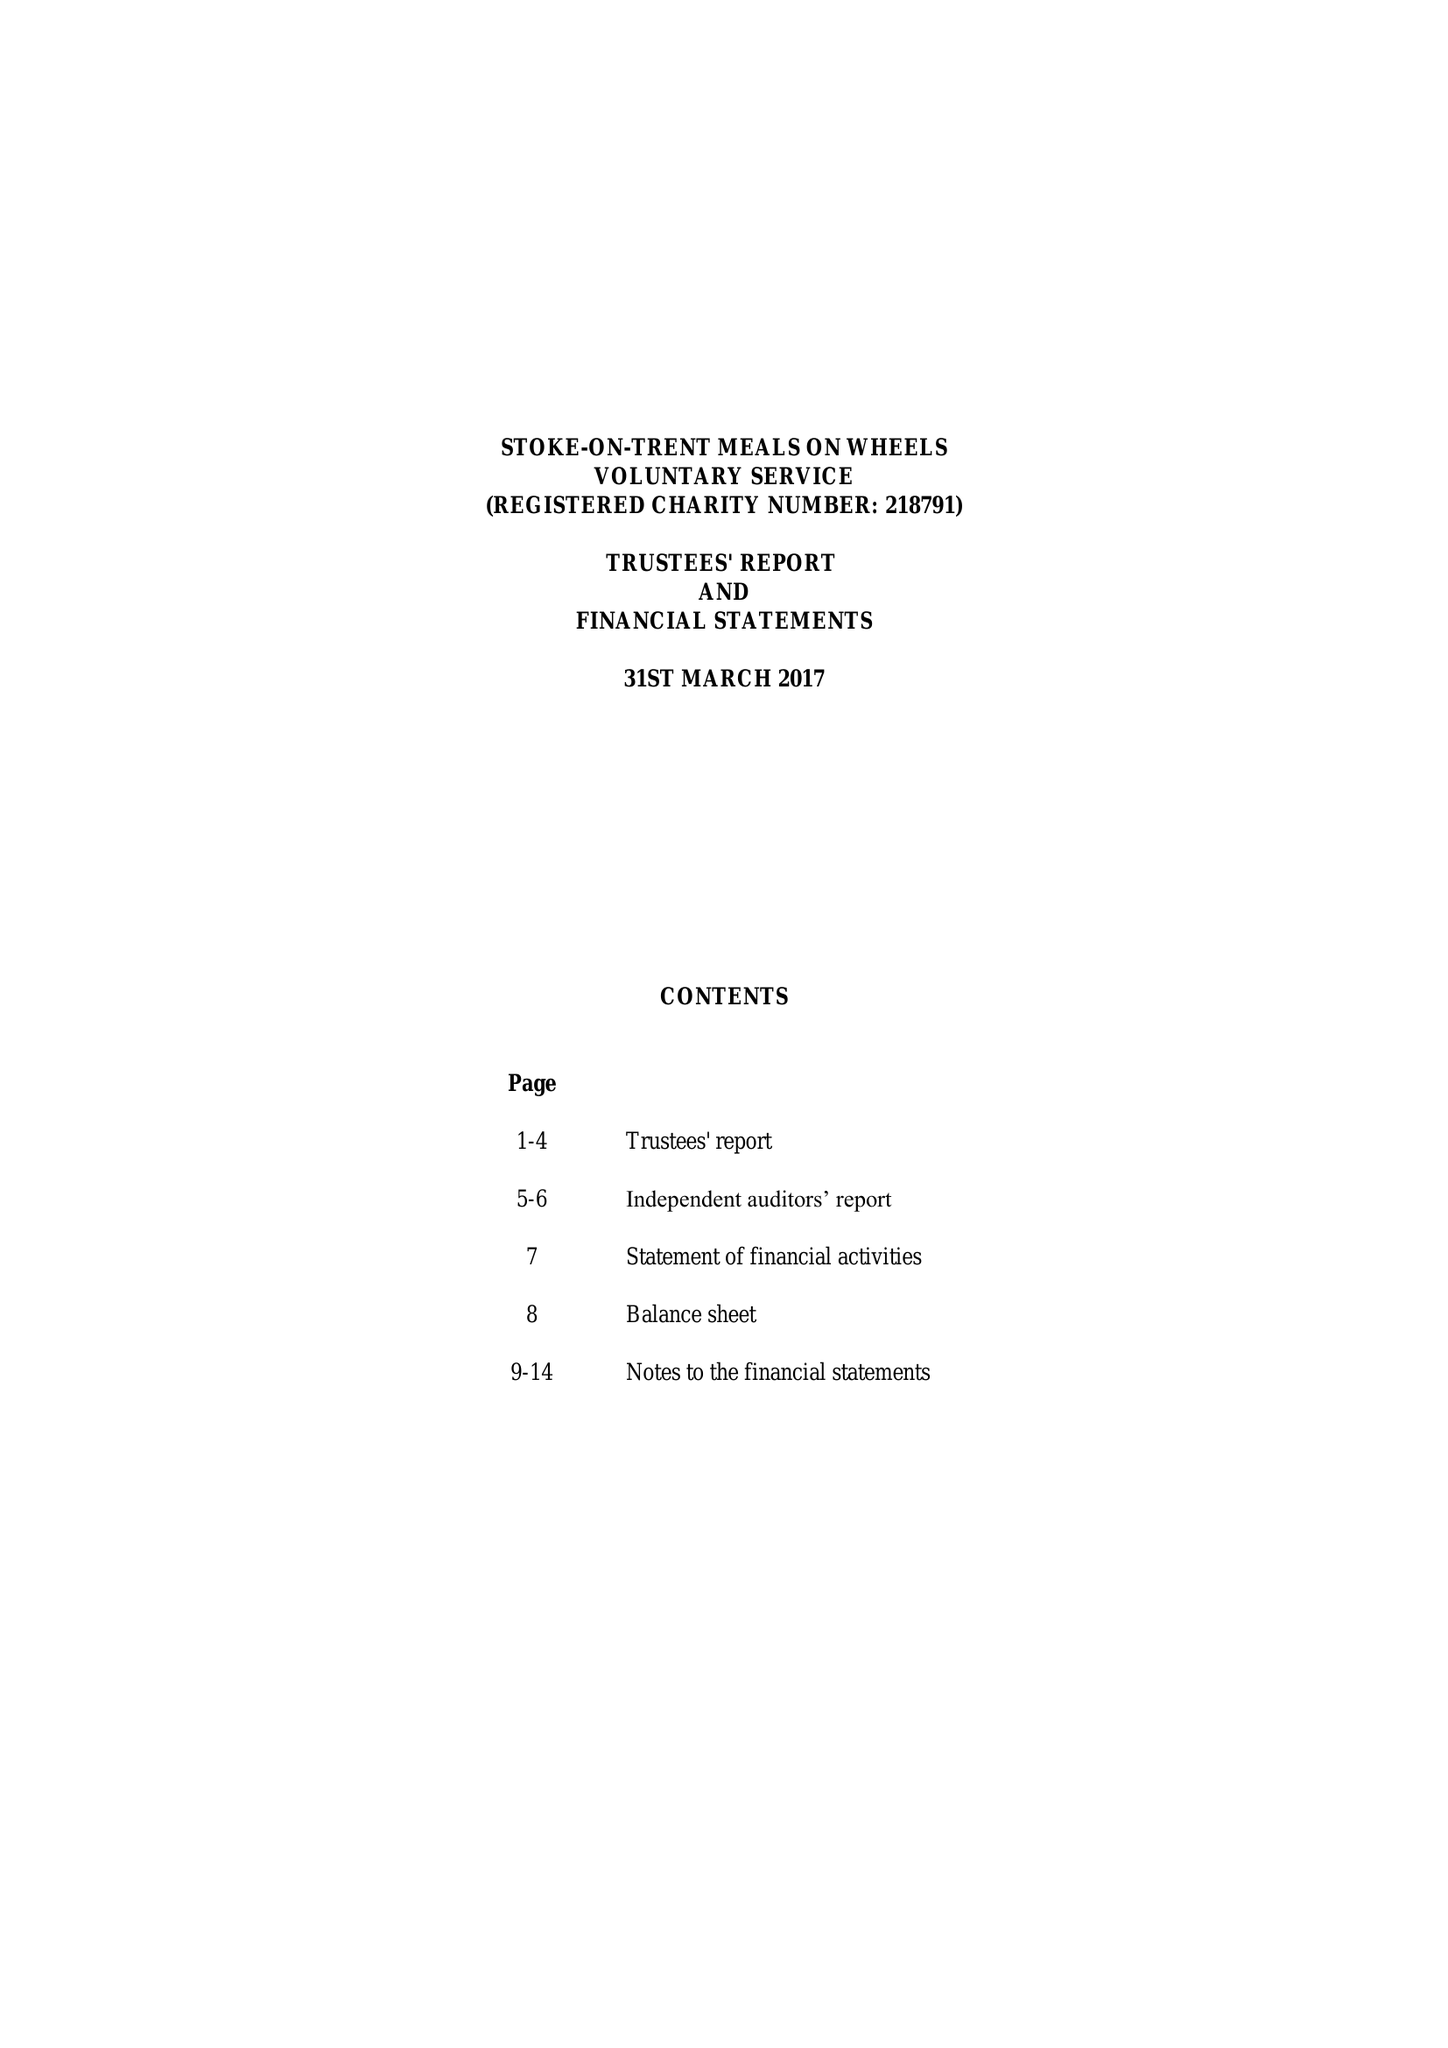What is the value for the address__postcode?
Answer the question using a single word or phrase. ST9 0EB 